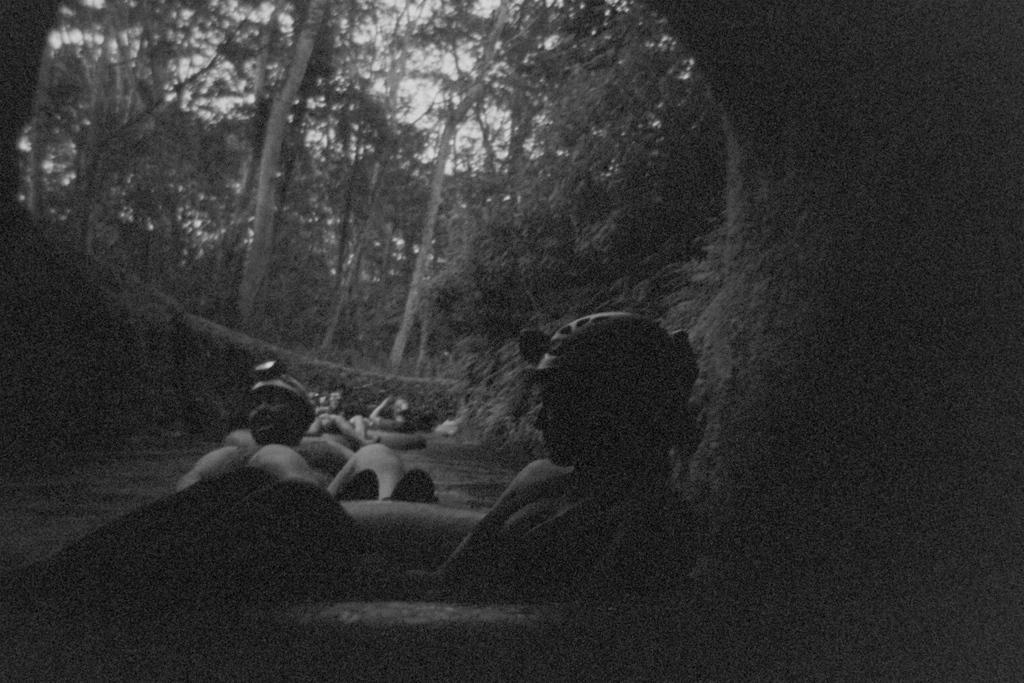How would you summarize this image in a sentence or two? It is a black and white image there are few people floating on the water surface and behind those people there are many tall trees. 